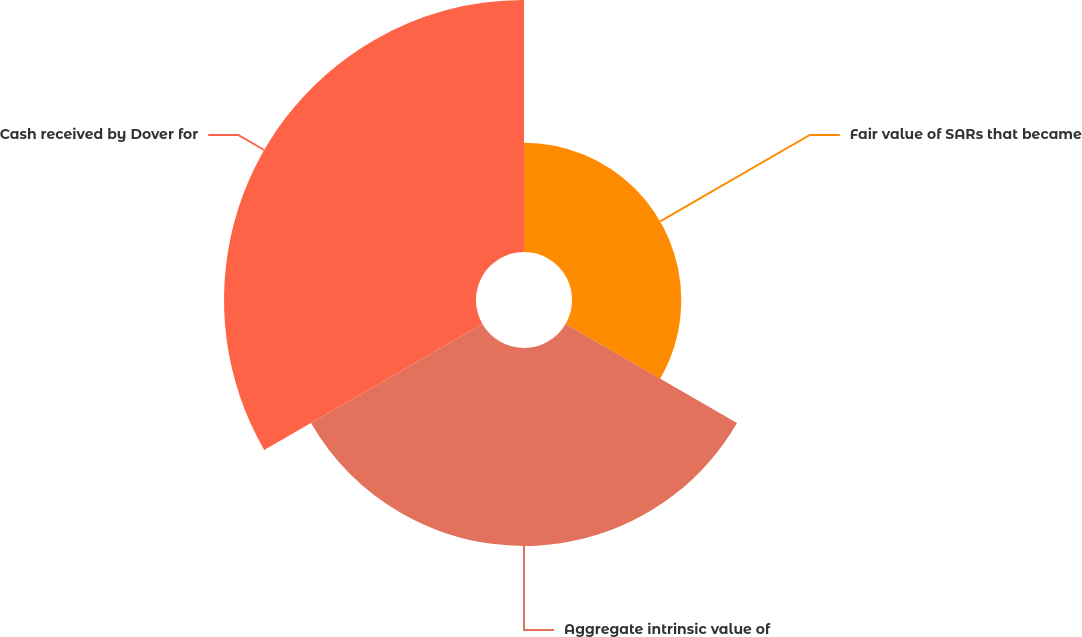Convert chart to OTSL. <chart><loc_0><loc_0><loc_500><loc_500><pie_chart><fcel>Fair value of SARs that became<fcel>Aggregate intrinsic value of<fcel>Cash received by Dover for<nl><fcel>19.54%<fcel>35.4%<fcel>45.07%<nl></chart> 